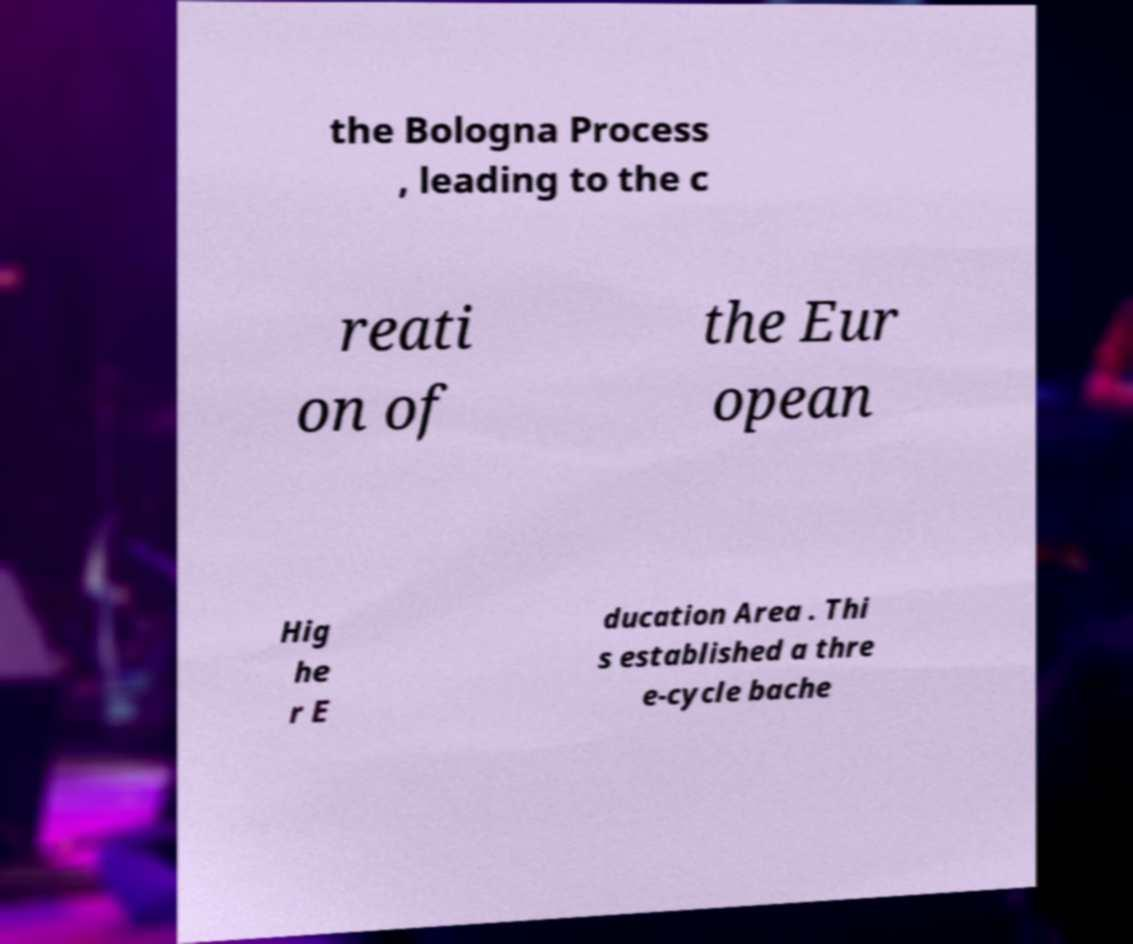Please identify and transcribe the text found in this image. the Bologna Process , leading to the c reati on of the Eur opean Hig he r E ducation Area . Thi s established a thre e-cycle bache 